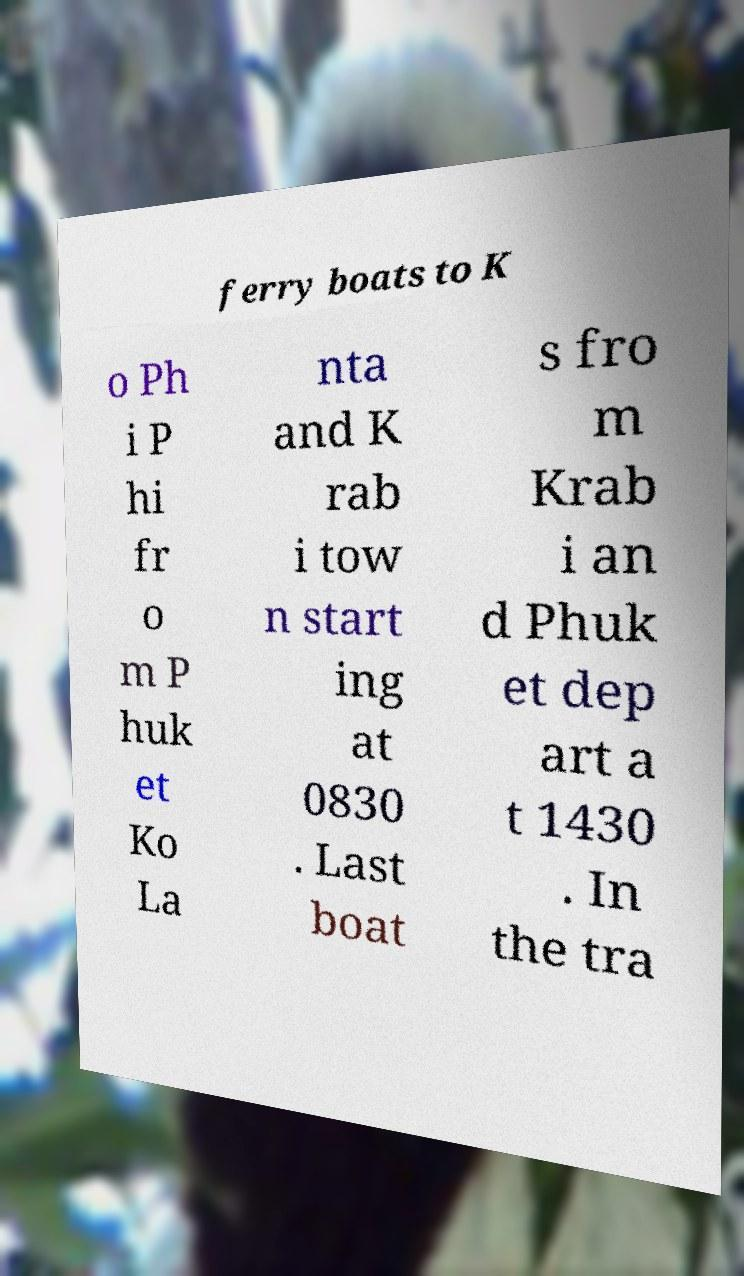Please identify and transcribe the text found in this image. ferry boats to K o Ph i P hi fr o m P huk et Ko La nta and K rab i tow n start ing at 0830 . Last boat s fro m Krab i an d Phuk et dep art a t 1430 . In the tra 